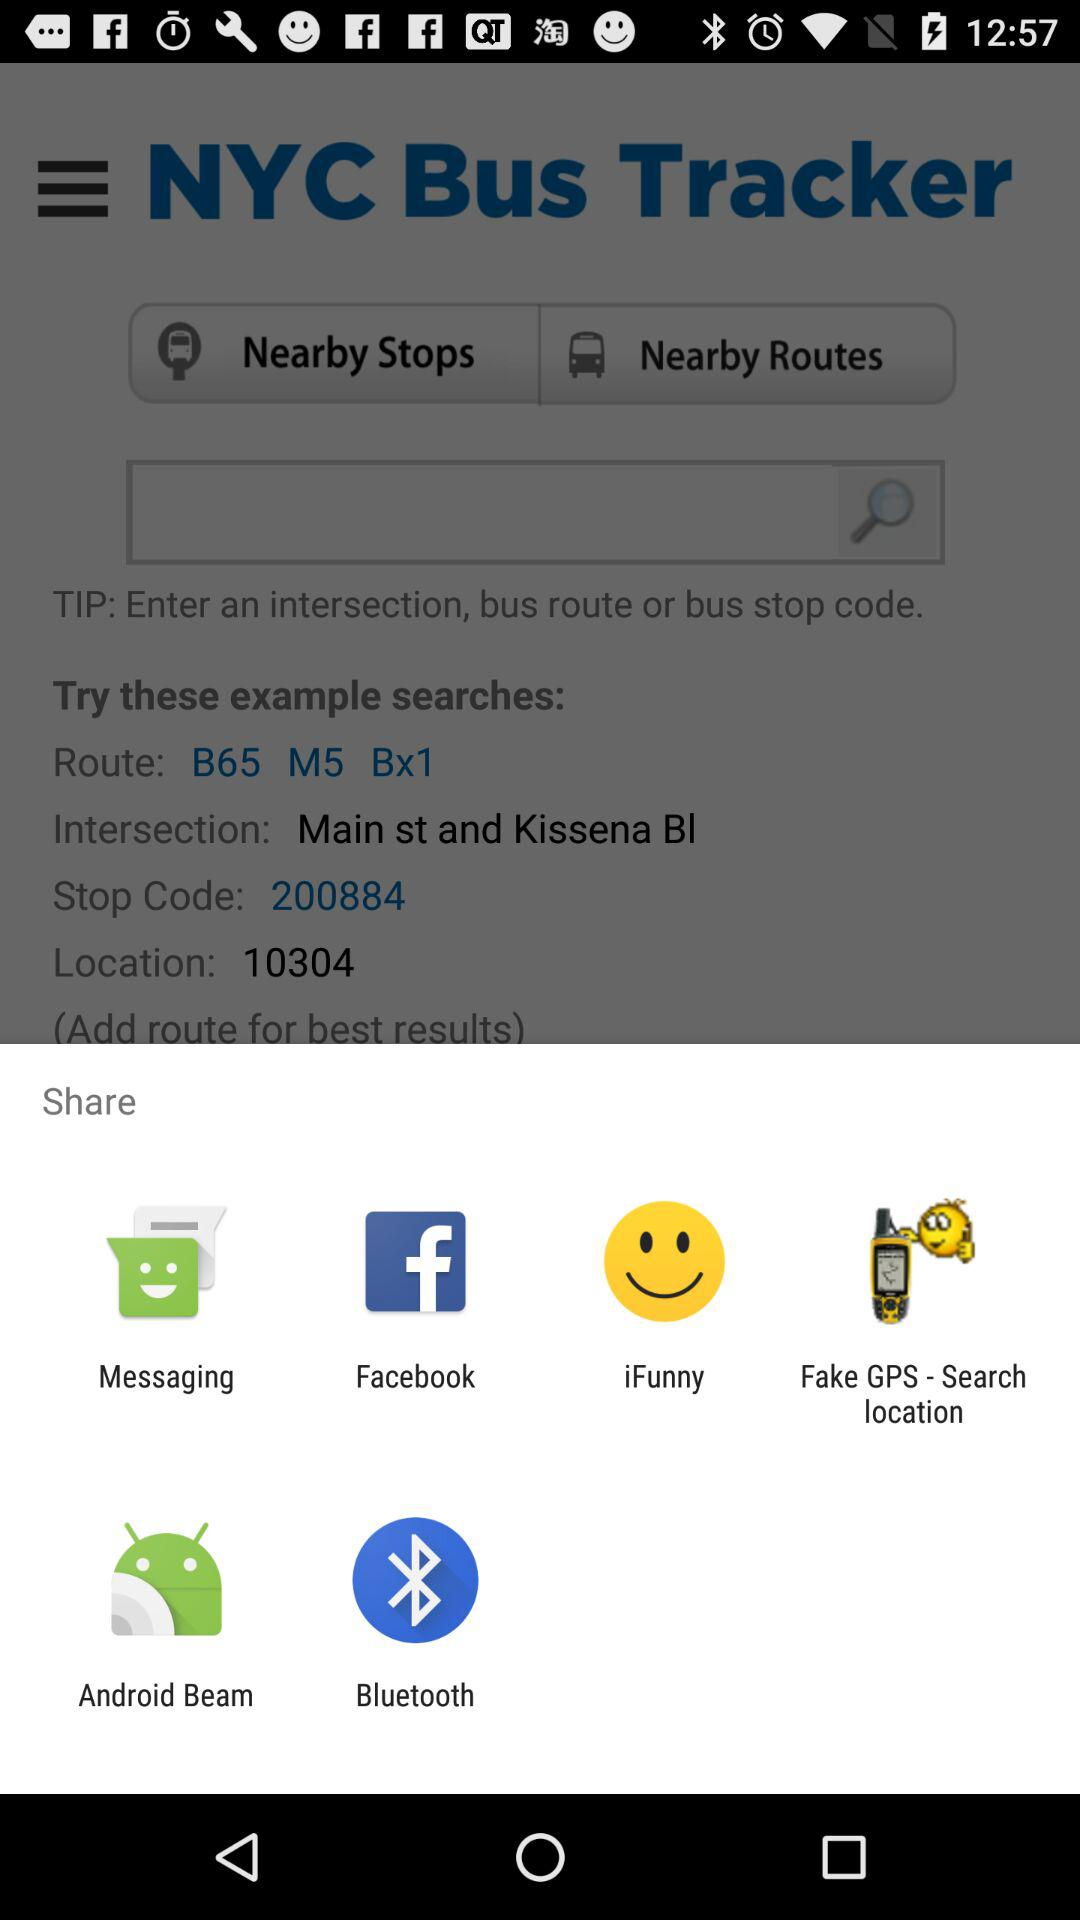What is the stop code? The stop code is 200884. 